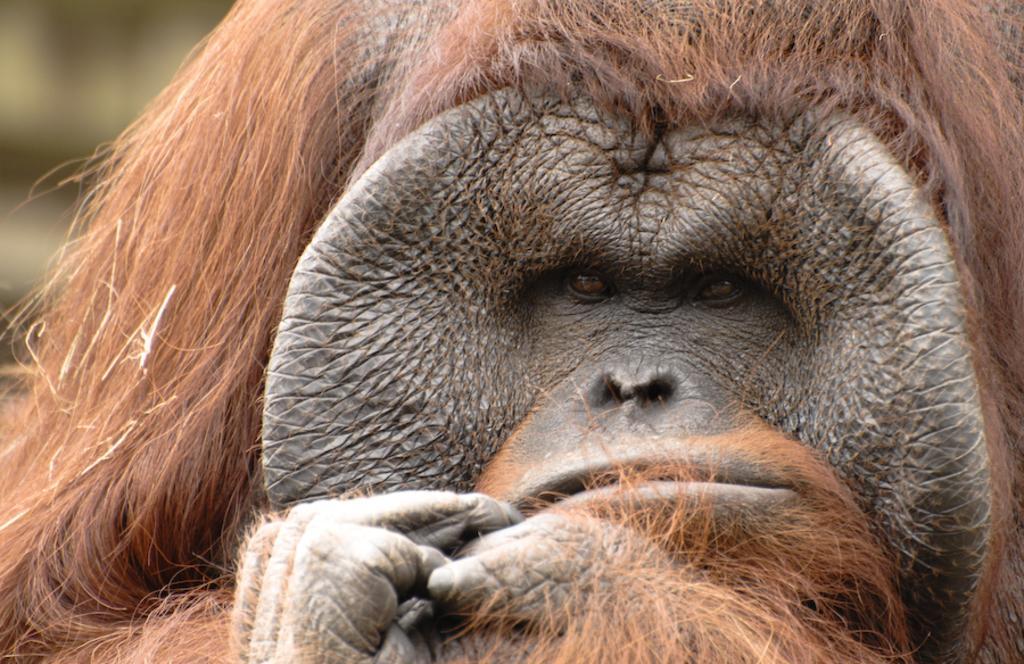Could you give a brief overview of what you see in this image? This image consists of an animal. Only the face is visible. It is in black color. 